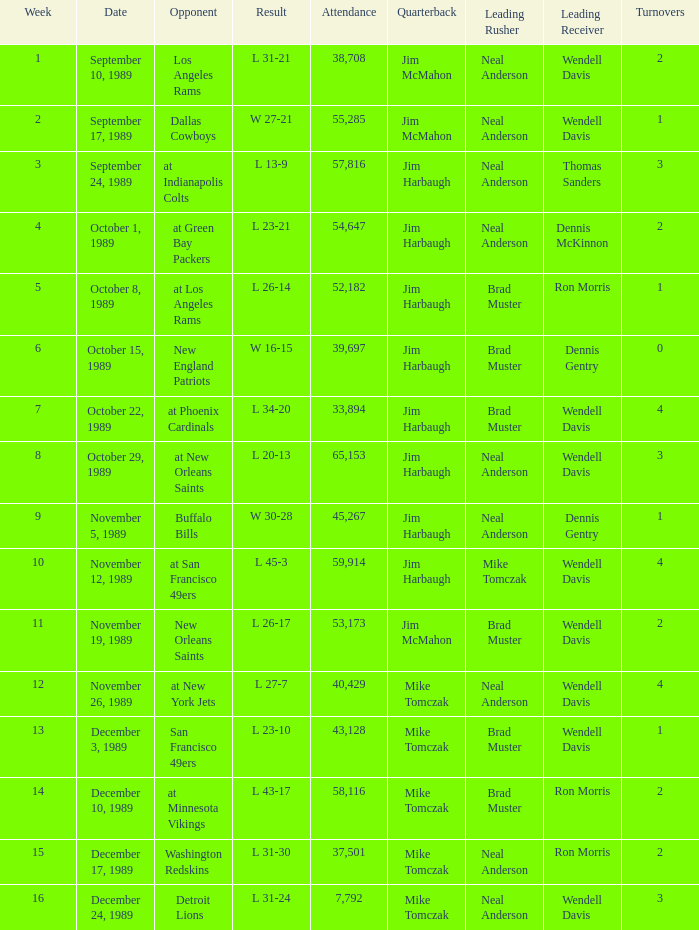For what week was the attendance 40,429? 12.0. 